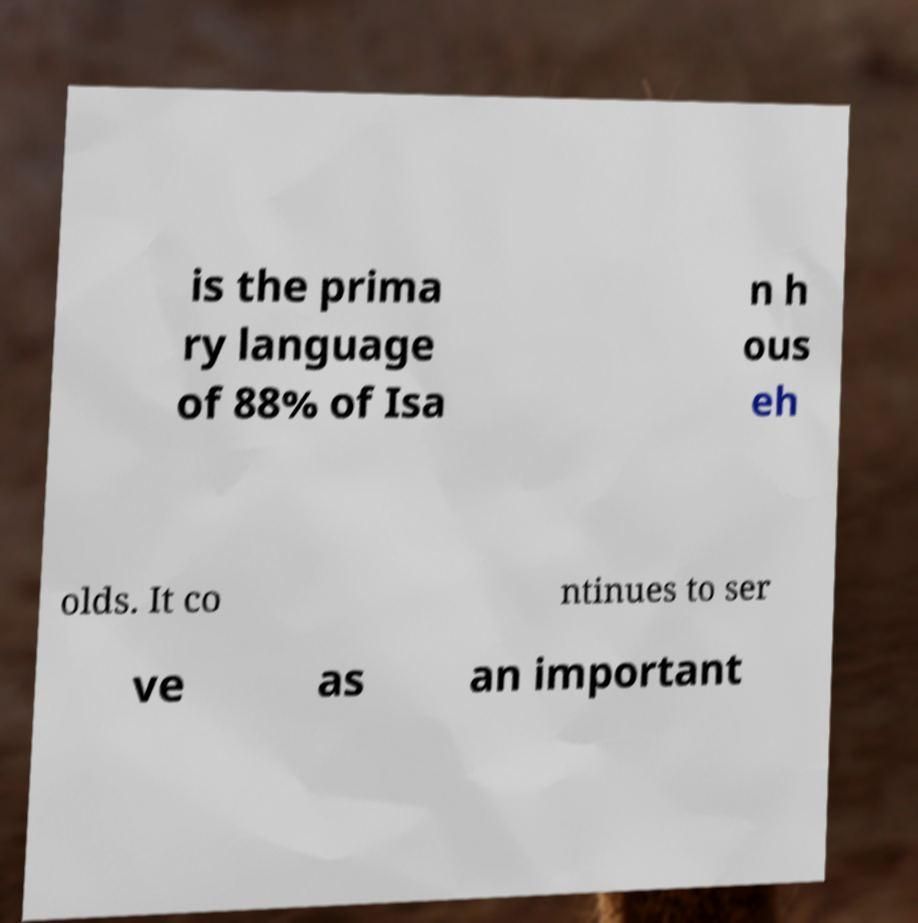I need the written content from this picture converted into text. Can you do that? is the prima ry language of 88% of Isa n h ous eh olds. It co ntinues to ser ve as an important 